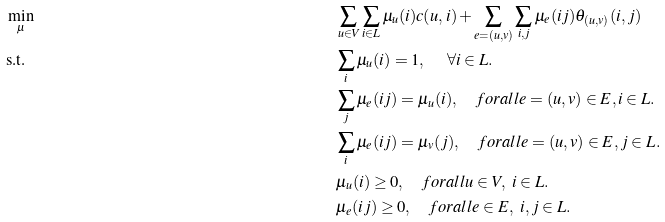<formula> <loc_0><loc_0><loc_500><loc_500>& \min _ { \mu } & & \sum _ { u \in V } \sum _ { i \in L } \mu _ { u } ( i ) c ( u , i ) + \sum _ { e = ( u , v ) } \sum _ { i , j } \mu _ { e } ( i j ) \theta _ { ( u , v ) } ( i , j ) \\ & \text {s.t.} & & \sum _ { i } \mu _ { u } ( i ) = 1 , \quad \ \forall i \in L . \\ & & & \sum _ { j } \mu _ { e } ( i j ) = \mu _ { u } ( i ) , \quad f o r a l l e = ( u , v ) \in E , i \in L . \\ & & & \sum _ { i } \mu _ { e } ( i j ) = \mu _ { v } ( j ) , \quad f o r a l l e = ( u , v ) \in E , j \in L . \\ & & & \mu _ { u } ( i ) \geq 0 , \quad f o r a l l u \in V , \ i \in L . \\ & & & \mu _ { e } ( i j ) \geq 0 , \quad f o r a l l e \in E , \ i , j \in L .</formula> 